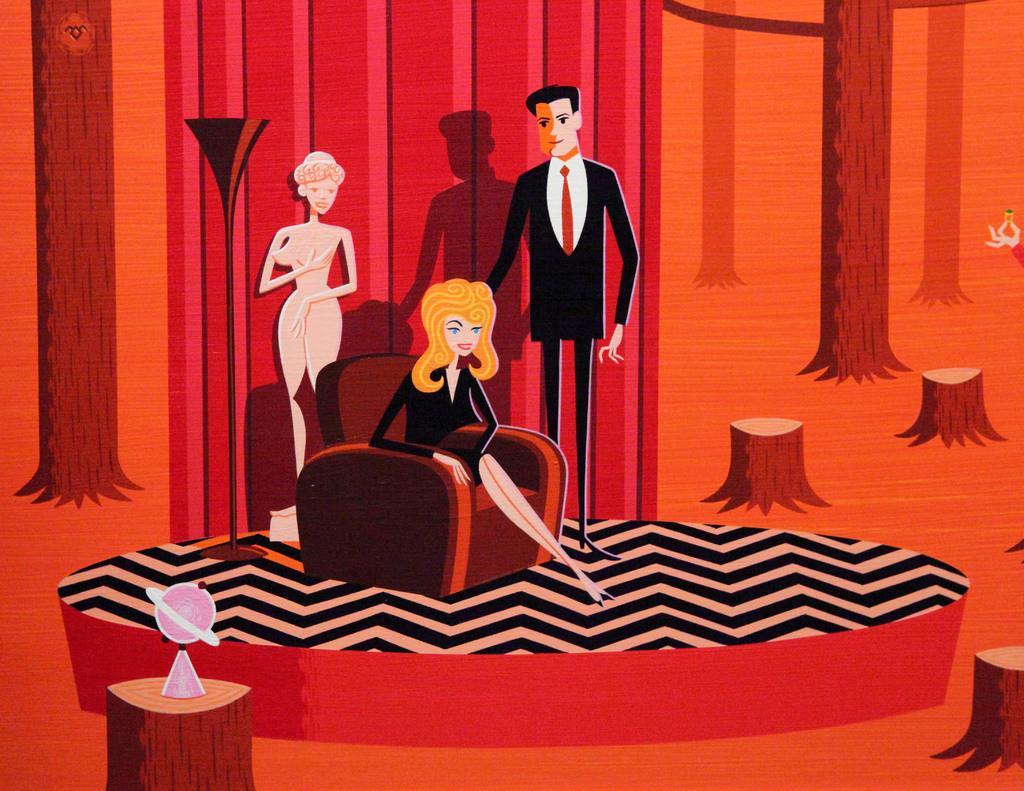In one or two sentences, can you explain what this image depicts? This is the cartoon image. In this picture, we see the illustration of the man and two women. We see the man and the women are standing. In the middle, we see a woman in the black dress is sitting on the sofa chair. At the bottom, we see the stem of the tree on which a globe is placed. On the right side, we see the stems of the trees. In the background, it is in orange, red and pink color. 